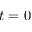<formula> <loc_0><loc_0><loc_500><loc_500>t = 0</formula> 